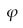Convert formula to latex. <formula><loc_0><loc_0><loc_500><loc_500>\varphi</formula> 